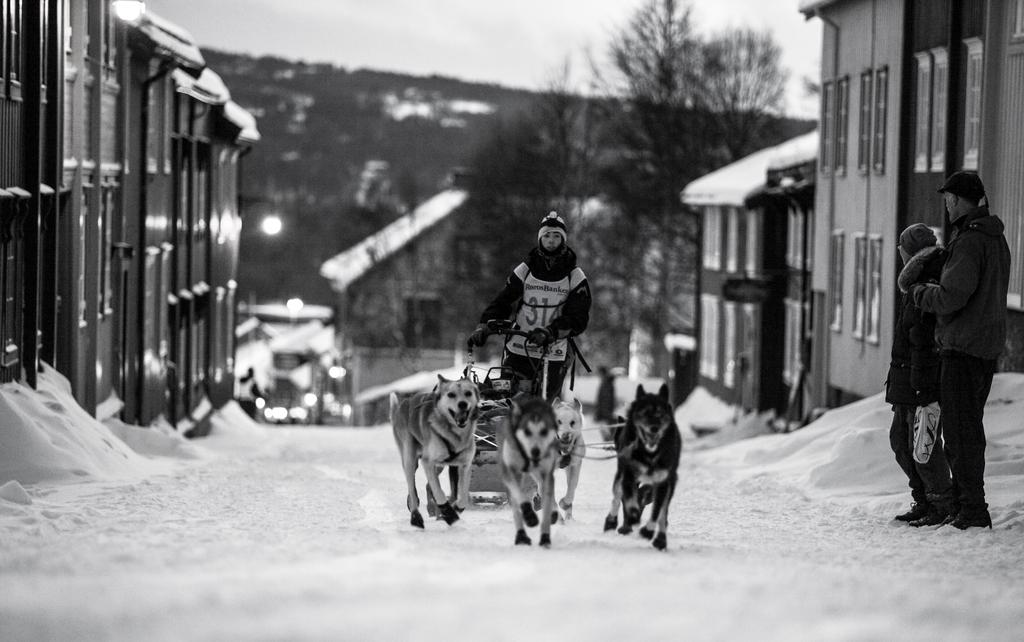Who or what is the main subject in the image? There is a person in the image. What is the person doing in the image? The person is carrying four dogs. What can be seen in the background of the image? There are buildings and trees in the background of the image. What type of furniture can be seen in the image? There is no furniture present in the image. 